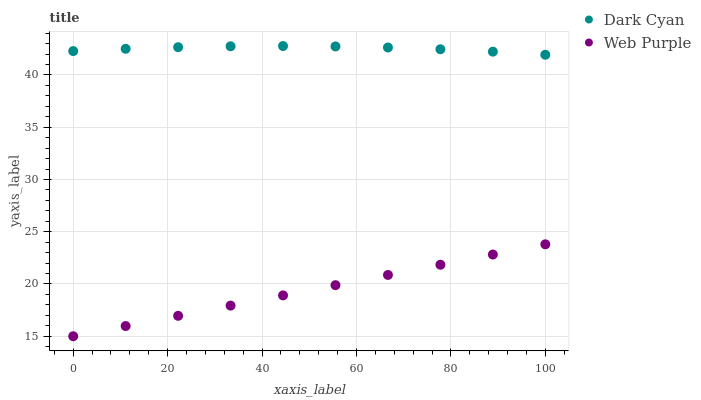Does Web Purple have the minimum area under the curve?
Answer yes or no. Yes. Does Dark Cyan have the maximum area under the curve?
Answer yes or no. Yes. Does Web Purple have the maximum area under the curve?
Answer yes or no. No. Is Web Purple the smoothest?
Answer yes or no. Yes. Is Dark Cyan the roughest?
Answer yes or no. Yes. Is Web Purple the roughest?
Answer yes or no. No. Does Web Purple have the lowest value?
Answer yes or no. Yes. Does Dark Cyan have the highest value?
Answer yes or no. Yes. Does Web Purple have the highest value?
Answer yes or no. No. Is Web Purple less than Dark Cyan?
Answer yes or no. Yes. Is Dark Cyan greater than Web Purple?
Answer yes or no. Yes. Does Web Purple intersect Dark Cyan?
Answer yes or no. No. 